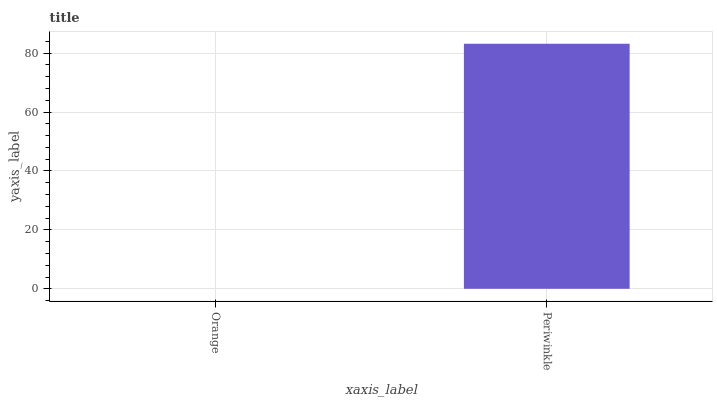Is Orange the minimum?
Answer yes or no. Yes. Is Periwinkle the maximum?
Answer yes or no. Yes. Is Periwinkle the minimum?
Answer yes or no. No. Is Periwinkle greater than Orange?
Answer yes or no. Yes. Is Orange less than Periwinkle?
Answer yes or no. Yes. Is Orange greater than Periwinkle?
Answer yes or no. No. Is Periwinkle less than Orange?
Answer yes or no. No. Is Periwinkle the high median?
Answer yes or no. Yes. Is Orange the low median?
Answer yes or no. Yes. Is Orange the high median?
Answer yes or no. No. Is Periwinkle the low median?
Answer yes or no. No. 